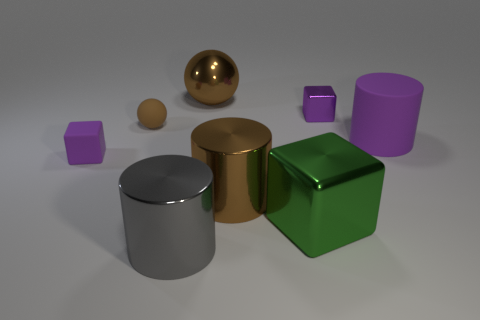Subtract all metallic cylinders. How many cylinders are left? 1 Subtract all purple cubes. How many cubes are left? 1 Add 1 small metal things. How many objects exist? 9 Subtract all cylinders. How many objects are left? 5 Subtract 3 blocks. How many blocks are left? 0 Subtract all red cubes. Subtract all purple balls. How many cubes are left? 3 Subtract all green cubes. How many red spheres are left? 0 Subtract all brown shiny spheres. Subtract all metal balls. How many objects are left? 6 Add 2 gray cylinders. How many gray cylinders are left? 3 Add 7 big cyan rubber balls. How many big cyan rubber balls exist? 7 